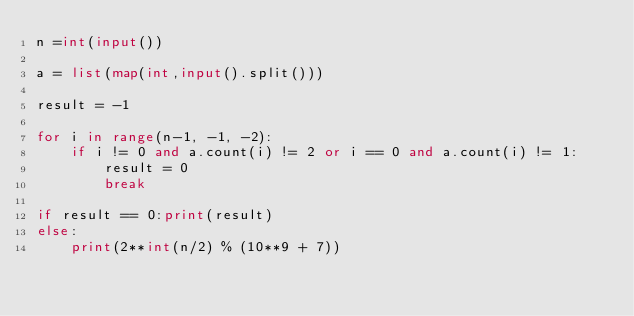Convert code to text. <code><loc_0><loc_0><loc_500><loc_500><_Python_>n =int(input())

a = list(map(int,input().split()))

result = -1

for i in range(n-1, -1, -2):
    if i != 0 and a.count(i) != 2 or i == 0 and a.count(i) != 1:
        result = 0
        break

if result == 0:print(result)
else:
    print(2**int(n/2) % (10**9 + 7))
</code> 